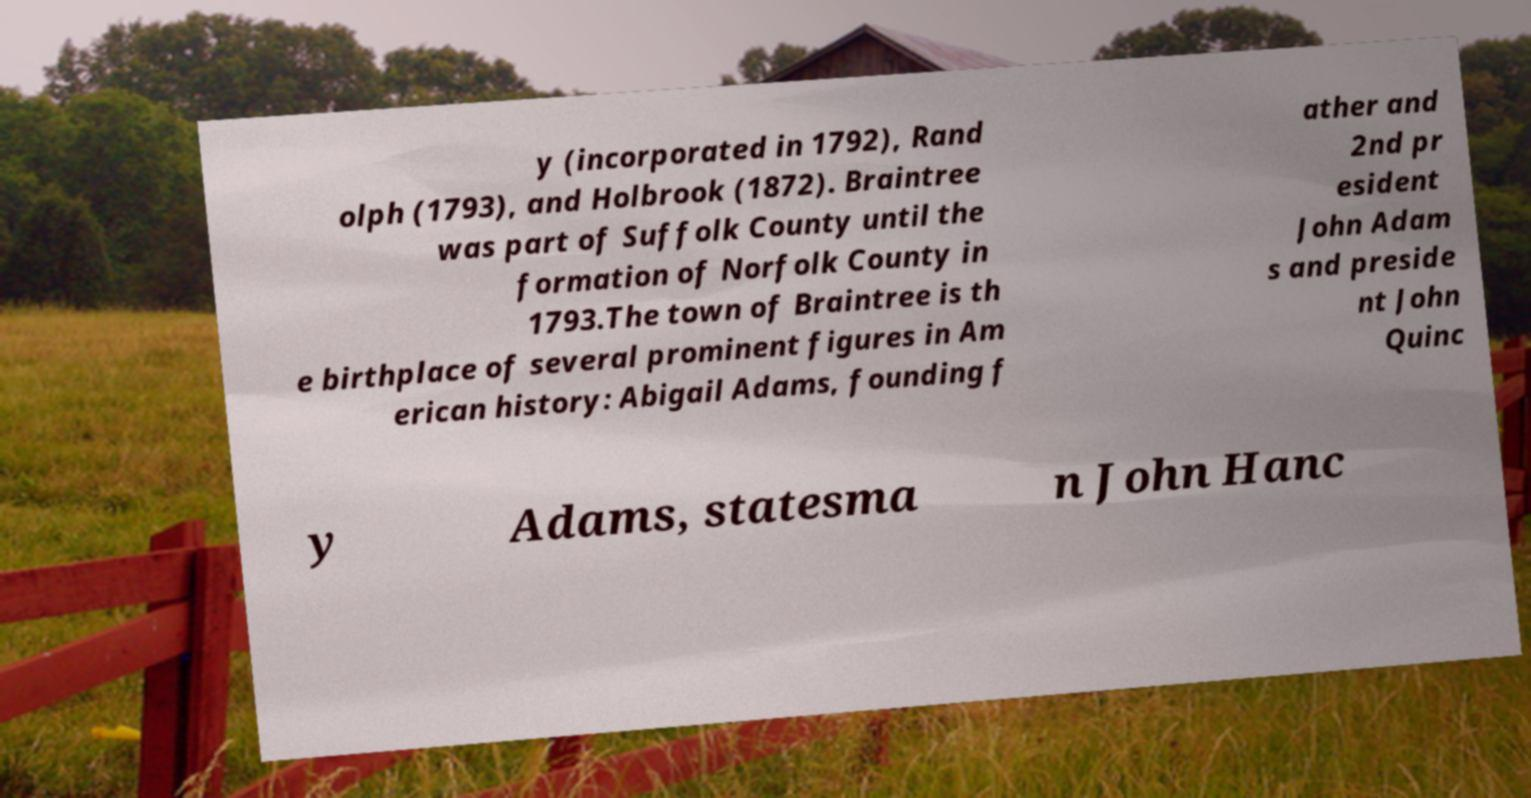What messages or text are displayed in this image? I need them in a readable, typed format. y (incorporated in 1792), Rand olph (1793), and Holbrook (1872). Braintree was part of Suffolk County until the formation of Norfolk County in 1793.The town of Braintree is th e birthplace of several prominent figures in Am erican history: Abigail Adams, founding f ather and 2nd pr esident John Adam s and preside nt John Quinc y Adams, statesma n John Hanc 